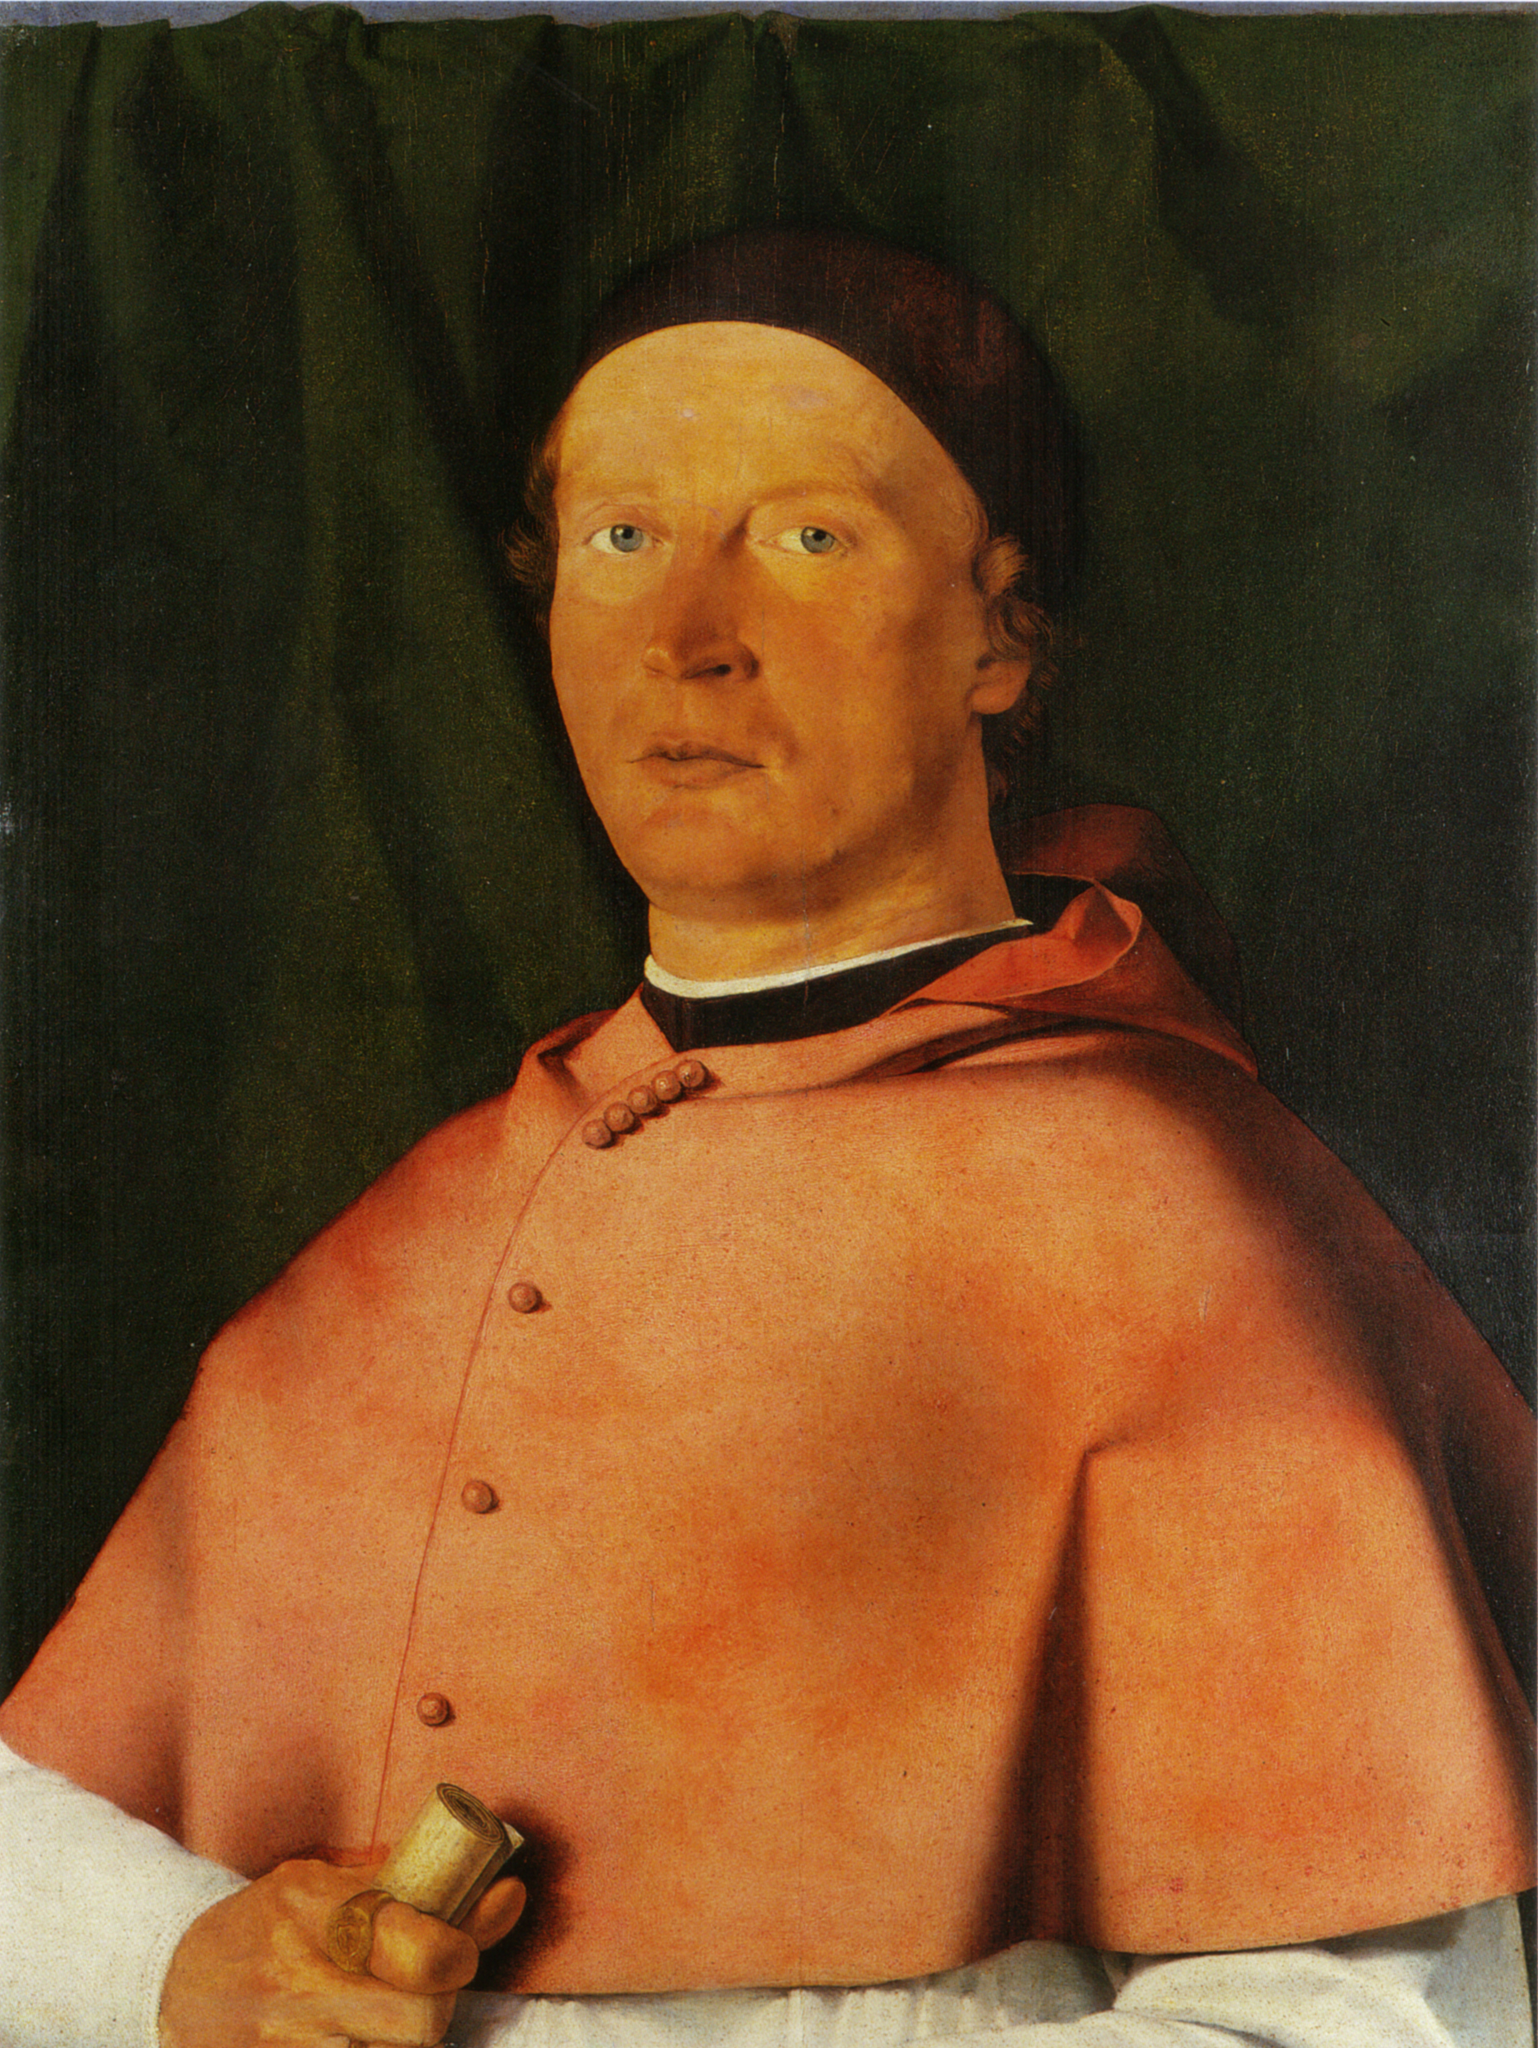What might the gold object in his hand represent? The small gold object clutched in the subject's hand could be a symbol of wealth or a personal emblem. Gold was a precious material, often reserved for the most valuable possessions. This object might be a seal used to stamp wax on documents, signifying the man's authority or his role in official or legal matters. It might also be a religious artifact, hinting at a possible clerical connection. Symbols in portraits of this period often held multiple layers of meaning, including personal, social, and sometimes spiritual significance. 